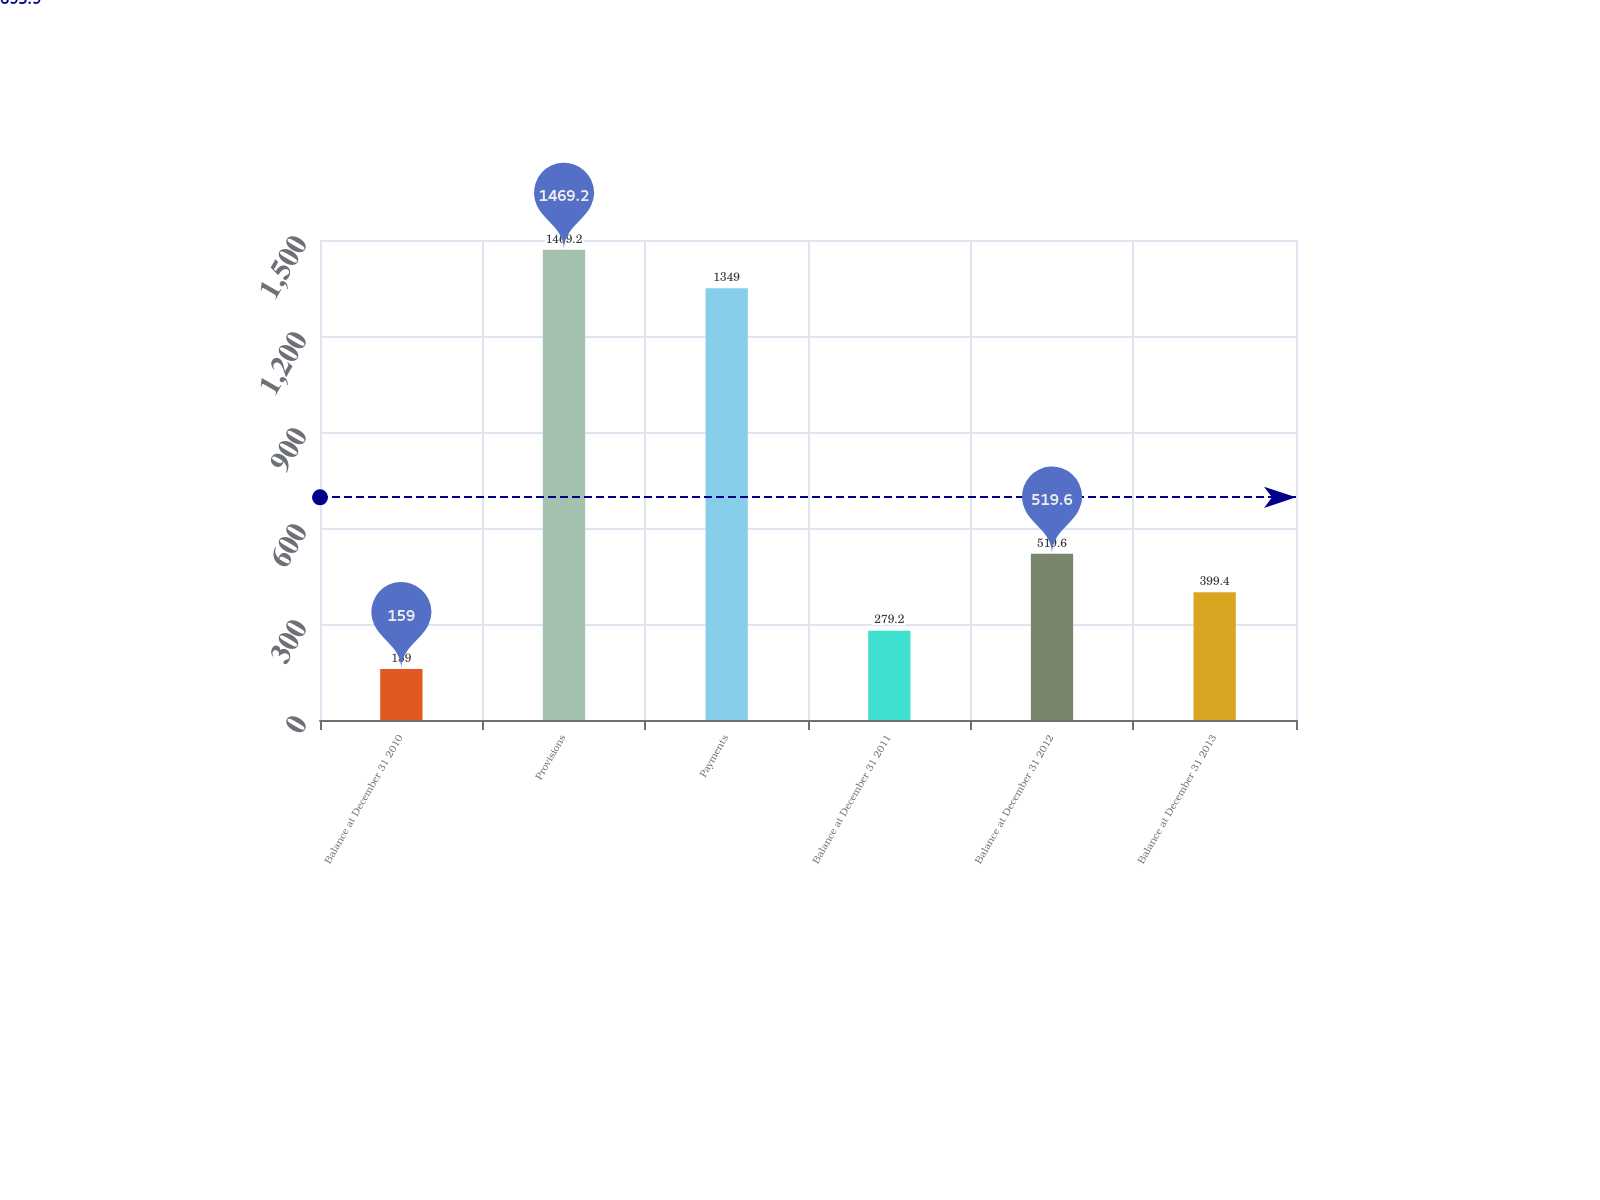Convert chart to OTSL. <chart><loc_0><loc_0><loc_500><loc_500><bar_chart><fcel>Balance at December 31 2010<fcel>Provisions<fcel>Payments<fcel>Balance at December 31 2011<fcel>Balance at December 31 2012<fcel>Balance at December 31 2013<nl><fcel>159<fcel>1469.2<fcel>1349<fcel>279.2<fcel>519.6<fcel>399.4<nl></chart> 